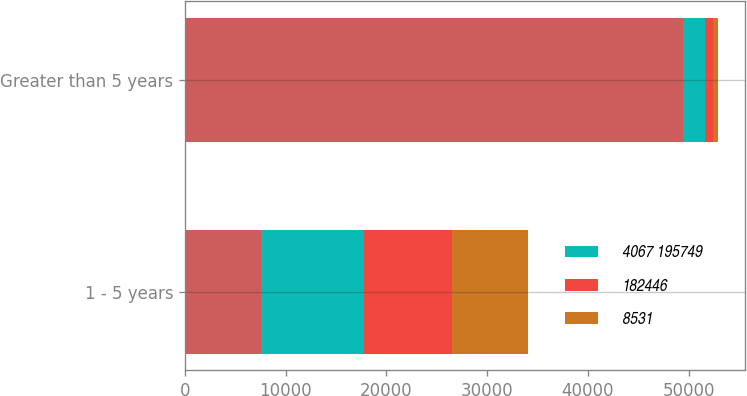Convert chart to OTSL. <chart><loc_0><loc_0><loc_500><loc_500><stacked_bar_chart><ecel><fcel>1 - 5 years<fcel>Greater than 5 years<nl><fcel>nan<fcel>7553<fcel>49440<nl><fcel>4067 195749<fcel>10201<fcel>2142<nl><fcel>182446<fcel>8747<fcel>817<nl><fcel>8531<fcel>7553<fcel>519<nl></chart> 